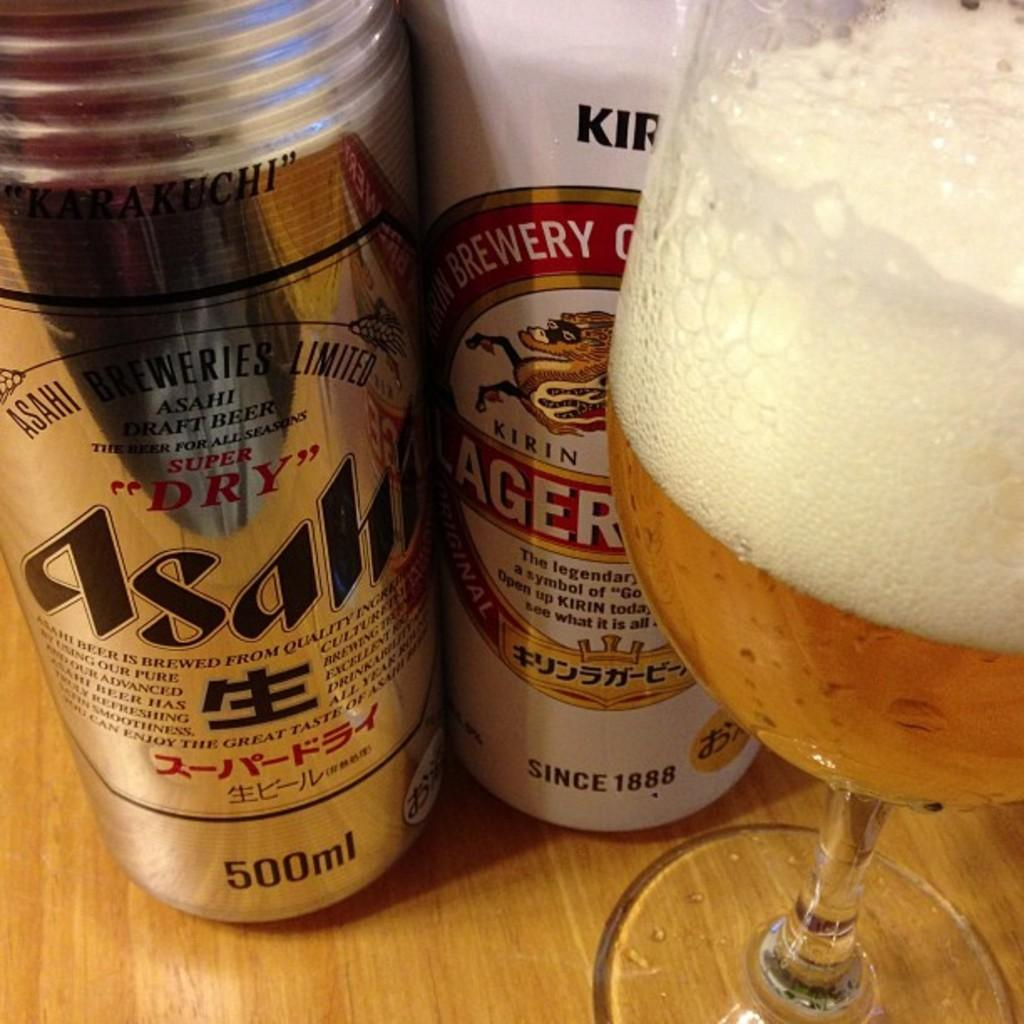<image>
Give a short and clear explanation of the subsequent image. Two cans of beer in front of a glass of it, the beers are 500 ml each. 